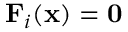<formula> <loc_0><loc_0><loc_500><loc_500>F _ { i } ( x ) = 0</formula> 